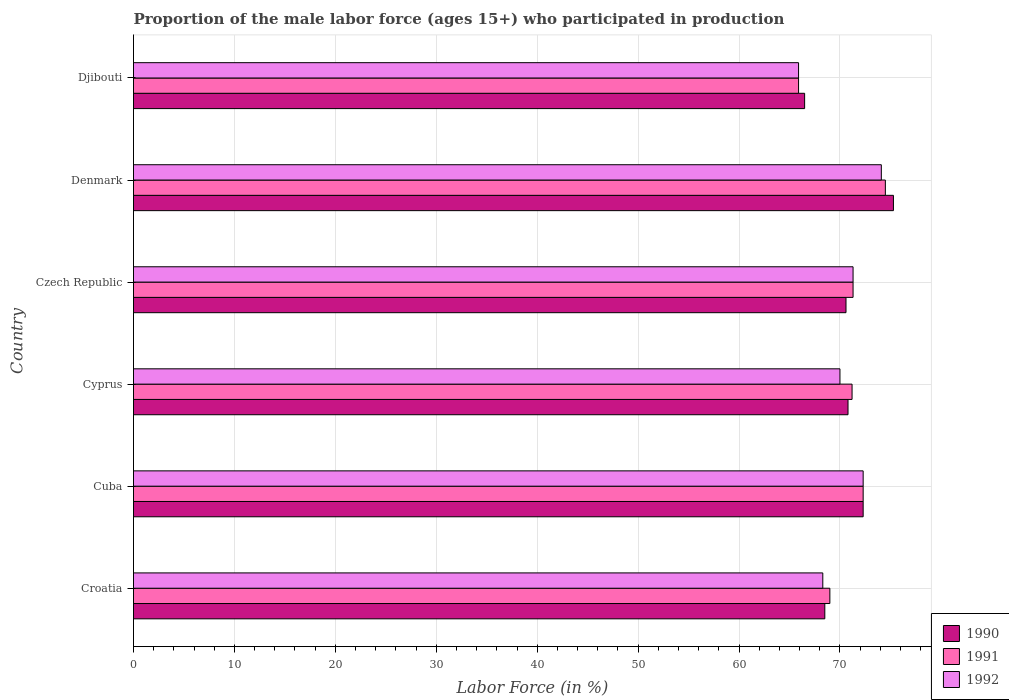Are the number of bars per tick equal to the number of legend labels?
Provide a short and direct response. Yes. How many bars are there on the 1st tick from the bottom?
Offer a very short reply. 3. What is the label of the 3rd group of bars from the top?
Give a very brief answer. Czech Republic. What is the proportion of the male labor force who participated in production in 1991 in Czech Republic?
Offer a terse response. 71.3. Across all countries, what is the maximum proportion of the male labor force who participated in production in 1990?
Your answer should be compact. 75.3. Across all countries, what is the minimum proportion of the male labor force who participated in production in 1990?
Make the answer very short. 66.5. In which country was the proportion of the male labor force who participated in production in 1992 maximum?
Give a very brief answer. Denmark. In which country was the proportion of the male labor force who participated in production in 1990 minimum?
Your response must be concise. Djibouti. What is the total proportion of the male labor force who participated in production in 1990 in the graph?
Provide a succinct answer. 424. What is the difference between the proportion of the male labor force who participated in production in 1990 in Croatia and that in Czech Republic?
Offer a terse response. -2.1. What is the difference between the proportion of the male labor force who participated in production in 1992 in Croatia and the proportion of the male labor force who participated in production in 1990 in Cuba?
Make the answer very short. -4. What is the average proportion of the male labor force who participated in production in 1991 per country?
Your response must be concise. 70.7. What is the difference between the proportion of the male labor force who participated in production in 1990 and proportion of the male labor force who participated in production in 1991 in Czech Republic?
Keep it short and to the point. -0.7. In how many countries, is the proportion of the male labor force who participated in production in 1992 greater than 30 %?
Give a very brief answer. 6. What is the ratio of the proportion of the male labor force who participated in production in 1992 in Croatia to that in Cuba?
Your response must be concise. 0.94. Is the difference between the proportion of the male labor force who participated in production in 1990 in Croatia and Cyprus greater than the difference between the proportion of the male labor force who participated in production in 1991 in Croatia and Cyprus?
Provide a succinct answer. No. What is the difference between the highest and the second highest proportion of the male labor force who participated in production in 1992?
Ensure brevity in your answer.  1.8. What is the difference between the highest and the lowest proportion of the male labor force who participated in production in 1991?
Your answer should be compact. 8.6. Is the sum of the proportion of the male labor force who participated in production in 1992 in Croatia and Cyprus greater than the maximum proportion of the male labor force who participated in production in 1990 across all countries?
Offer a terse response. Yes. What does the 3rd bar from the top in Denmark represents?
Provide a short and direct response. 1990. Are all the bars in the graph horizontal?
Your response must be concise. Yes. How many countries are there in the graph?
Your response must be concise. 6. Are the values on the major ticks of X-axis written in scientific E-notation?
Make the answer very short. No. Does the graph contain any zero values?
Provide a short and direct response. No. What is the title of the graph?
Your answer should be compact. Proportion of the male labor force (ages 15+) who participated in production. What is the label or title of the Y-axis?
Provide a short and direct response. Country. What is the Labor Force (in %) of 1990 in Croatia?
Offer a terse response. 68.5. What is the Labor Force (in %) of 1991 in Croatia?
Offer a terse response. 69. What is the Labor Force (in %) of 1992 in Croatia?
Offer a terse response. 68.3. What is the Labor Force (in %) in 1990 in Cuba?
Offer a very short reply. 72.3. What is the Labor Force (in %) of 1991 in Cuba?
Give a very brief answer. 72.3. What is the Labor Force (in %) in 1992 in Cuba?
Give a very brief answer. 72.3. What is the Labor Force (in %) in 1990 in Cyprus?
Offer a very short reply. 70.8. What is the Labor Force (in %) in 1991 in Cyprus?
Ensure brevity in your answer.  71.2. What is the Labor Force (in %) in 1990 in Czech Republic?
Offer a very short reply. 70.6. What is the Labor Force (in %) in 1991 in Czech Republic?
Offer a terse response. 71.3. What is the Labor Force (in %) in 1992 in Czech Republic?
Provide a succinct answer. 71.3. What is the Labor Force (in %) in 1990 in Denmark?
Your answer should be compact. 75.3. What is the Labor Force (in %) of 1991 in Denmark?
Offer a terse response. 74.5. What is the Labor Force (in %) in 1992 in Denmark?
Ensure brevity in your answer.  74.1. What is the Labor Force (in %) in 1990 in Djibouti?
Give a very brief answer. 66.5. What is the Labor Force (in %) in 1991 in Djibouti?
Give a very brief answer. 65.9. What is the Labor Force (in %) in 1992 in Djibouti?
Offer a very short reply. 65.9. Across all countries, what is the maximum Labor Force (in %) of 1990?
Your response must be concise. 75.3. Across all countries, what is the maximum Labor Force (in %) of 1991?
Give a very brief answer. 74.5. Across all countries, what is the maximum Labor Force (in %) in 1992?
Ensure brevity in your answer.  74.1. Across all countries, what is the minimum Labor Force (in %) of 1990?
Offer a terse response. 66.5. Across all countries, what is the minimum Labor Force (in %) in 1991?
Your answer should be very brief. 65.9. Across all countries, what is the minimum Labor Force (in %) in 1992?
Make the answer very short. 65.9. What is the total Labor Force (in %) in 1990 in the graph?
Your answer should be compact. 424. What is the total Labor Force (in %) of 1991 in the graph?
Keep it short and to the point. 424.2. What is the total Labor Force (in %) of 1992 in the graph?
Make the answer very short. 421.9. What is the difference between the Labor Force (in %) in 1990 in Croatia and that in Cyprus?
Make the answer very short. -2.3. What is the difference between the Labor Force (in %) of 1991 in Croatia and that in Cyprus?
Provide a short and direct response. -2.2. What is the difference between the Labor Force (in %) of 1992 in Croatia and that in Cyprus?
Keep it short and to the point. -1.7. What is the difference between the Labor Force (in %) of 1991 in Croatia and that in Czech Republic?
Provide a succinct answer. -2.3. What is the difference between the Labor Force (in %) of 1992 in Croatia and that in Czech Republic?
Provide a succinct answer. -3. What is the difference between the Labor Force (in %) of 1990 in Croatia and that in Djibouti?
Keep it short and to the point. 2. What is the difference between the Labor Force (in %) in 1991 in Cuba and that in Cyprus?
Keep it short and to the point. 1.1. What is the difference between the Labor Force (in %) of 1992 in Cuba and that in Cyprus?
Your response must be concise. 2.3. What is the difference between the Labor Force (in %) in 1992 in Cuba and that in Czech Republic?
Ensure brevity in your answer.  1. What is the difference between the Labor Force (in %) of 1990 in Cuba and that in Denmark?
Give a very brief answer. -3. What is the difference between the Labor Force (in %) in 1990 in Cuba and that in Djibouti?
Offer a very short reply. 5.8. What is the difference between the Labor Force (in %) of 1991 in Cuba and that in Djibouti?
Make the answer very short. 6.4. What is the difference between the Labor Force (in %) in 1992 in Cyprus and that in Czech Republic?
Provide a short and direct response. -1.3. What is the difference between the Labor Force (in %) in 1992 in Cyprus and that in Denmark?
Your response must be concise. -4.1. What is the difference between the Labor Force (in %) in 1990 in Cyprus and that in Djibouti?
Your response must be concise. 4.3. What is the difference between the Labor Force (in %) in 1991 in Cyprus and that in Djibouti?
Your response must be concise. 5.3. What is the difference between the Labor Force (in %) of 1990 in Czech Republic and that in Djibouti?
Your response must be concise. 4.1. What is the difference between the Labor Force (in %) in 1992 in Czech Republic and that in Djibouti?
Make the answer very short. 5.4. What is the difference between the Labor Force (in %) of 1992 in Denmark and that in Djibouti?
Provide a short and direct response. 8.2. What is the difference between the Labor Force (in %) of 1991 in Croatia and the Labor Force (in %) of 1992 in Cuba?
Offer a terse response. -3.3. What is the difference between the Labor Force (in %) of 1990 in Croatia and the Labor Force (in %) of 1991 in Cyprus?
Your answer should be compact. -2.7. What is the difference between the Labor Force (in %) in 1990 in Croatia and the Labor Force (in %) in 1991 in Czech Republic?
Provide a short and direct response. -2.8. What is the difference between the Labor Force (in %) in 1990 in Croatia and the Labor Force (in %) in 1992 in Czech Republic?
Your answer should be very brief. -2.8. What is the difference between the Labor Force (in %) in 1991 in Croatia and the Labor Force (in %) in 1992 in Czech Republic?
Your response must be concise. -2.3. What is the difference between the Labor Force (in %) in 1990 in Croatia and the Labor Force (in %) in 1991 in Denmark?
Provide a succinct answer. -6. What is the difference between the Labor Force (in %) of 1990 in Croatia and the Labor Force (in %) of 1992 in Djibouti?
Give a very brief answer. 2.6. What is the difference between the Labor Force (in %) in 1990 in Cuba and the Labor Force (in %) in 1992 in Cyprus?
Offer a very short reply. 2.3. What is the difference between the Labor Force (in %) in 1990 in Cuba and the Labor Force (in %) in 1992 in Czech Republic?
Your response must be concise. 1. What is the difference between the Labor Force (in %) of 1990 in Cuba and the Labor Force (in %) of 1991 in Denmark?
Offer a terse response. -2.2. What is the difference between the Labor Force (in %) in 1990 in Cyprus and the Labor Force (in %) in 1991 in Czech Republic?
Give a very brief answer. -0.5. What is the difference between the Labor Force (in %) in 1990 in Cyprus and the Labor Force (in %) in 1992 in Czech Republic?
Give a very brief answer. -0.5. What is the difference between the Labor Force (in %) of 1991 in Cyprus and the Labor Force (in %) of 1992 in Czech Republic?
Your answer should be very brief. -0.1. What is the difference between the Labor Force (in %) in 1990 in Cyprus and the Labor Force (in %) in 1991 in Denmark?
Provide a short and direct response. -3.7. What is the difference between the Labor Force (in %) of 1990 in Cyprus and the Labor Force (in %) of 1992 in Denmark?
Your response must be concise. -3.3. What is the difference between the Labor Force (in %) of 1990 in Cyprus and the Labor Force (in %) of 1992 in Djibouti?
Give a very brief answer. 4.9. What is the difference between the Labor Force (in %) of 1990 in Czech Republic and the Labor Force (in %) of 1991 in Denmark?
Offer a very short reply. -3.9. What is the difference between the Labor Force (in %) of 1990 in Czech Republic and the Labor Force (in %) of 1992 in Denmark?
Your response must be concise. -3.5. What is the difference between the Labor Force (in %) of 1990 in Czech Republic and the Labor Force (in %) of 1992 in Djibouti?
Your answer should be very brief. 4.7. What is the difference between the Labor Force (in %) of 1991 in Czech Republic and the Labor Force (in %) of 1992 in Djibouti?
Your response must be concise. 5.4. What is the difference between the Labor Force (in %) in 1990 in Denmark and the Labor Force (in %) in 1992 in Djibouti?
Keep it short and to the point. 9.4. What is the difference between the Labor Force (in %) in 1991 in Denmark and the Labor Force (in %) in 1992 in Djibouti?
Keep it short and to the point. 8.6. What is the average Labor Force (in %) in 1990 per country?
Provide a succinct answer. 70.67. What is the average Labor Force (in %) in 1991 per country?
Make the answer very short. 70.7. What is the average Labor Force (in %) in 1992 per country?
Provide a succinct answer. 70.32. What is the difference between the Labor Force (in %) in 1991 and Labor Force (in %) in 1992 in Croatia?
Make the answer very short. 0.7. What is the difference between the Labor Force (in %) of 1991 and Labor Force (in %) of 1992 in Cuba?
Ensure brevity in your answer.  0. What is the difference between the Labor Force (in %) of 1990 and Labor Force (in %) of 1992 in Cyprus?
Offer a very short reply. 0.8. What is the difference between the Labor Force (in %) in 1991 and Labor Force (in %) in 1992 in Denmark?
Provide a short and direct response. 0.4. What is the difference between the Labor Force (in %) of 1990 and Labor Force (in %) of 1992 in Djibouti?
Your answer should be compact. 0.6. What is the ratio of the Labor Force (in %) of 1990 in Croatia to that in Cuba?
Provide a succinct answer. 0.95. What is the ratio of the Labor Force (in %) of 1991 in Croatia to that in Cuba?
Provide a short and direct response. 0.95. What is the ratio of the Labor Force (in %) of 1992 in Croatia to that in Cuba?
Your response must be concise. 0.94. What is the ratio of the Labor Force (in %) in 1990 in Croatia to that in Cyprus?
Your response must be concise. 0.97. What is the ratio of the Labor Force (in %) in 1991 in Croatia to that in Cyprus?
Provide a succinct answer. 0.97. What is the ratio of the Labor Force (in %) in 1992 in Croatia to that in Cyprus?
Provide a succinct answer. 0.98. What is the ratio of the Labor Force (in %) of 1990 in Croatia to that in Czech Republic?
Your response must be concise. 0.97. What is the ratio of the Labor Force (in %) of 1991 in Croatia to that in Czech Republic?
Offer a very short reply. 0.97. What is the ratio of the Labor Force (in %) of 1992 in Croatia to that in Czech Republic?
Your answer should be very brief. 0.96. What is the ratio of the Labor Force (in %) of 1990 in Croatia to that in Denmark?
Provide a succinct answer. 0.91. What is the ratio of the Labor Force (in %) of 1991 in Croatia to that in Denmark?
Provide a short and direct response. 0.93. What is the ratio of the Labor Force (in %) of 1992 in Croatia to that in Denmark?
Make the answer very short. 0.92. What is the ratio of the Labor Force (in %) in 1990 in Croatia to that in Djibouti?
Your response must be concise. 1.03. What is the ratio of the Labor Force (in %) in 1991 in Croatia to that in Djibouti?
Provide a short and direct response. 1.05. What is the ratio of the Labor Force (in %) in 1992 in Croatia to that in Djibouti?
Your response must be concise. 1.04. What is the ratio of the Labor Force (in %) in 1990 in Cuba to that in Cyprus?
Provide a succinct answer. 1.02. What is the ratio of the Labor Force (in %) of 1991 in Cuba to that in Cyprus?
Offer a terse response. 1.02. What is the ratio of the Labor Force (in %) of 1992 in Cuba to that in Cyprus?
Your answer should be very brief. 1.03. What is the ratio of the Labor Force (in %) in 1990 in Cuba to that in Czech Republic?
Your answer should be very brief. 1.02. What is the ratio of the Labor Force (in %) of 1991 in Cuba to that in Czech Republic?
Your answer should be compact. 1.01. What is the ratio of the Labor Force (in %) in 1992 in Cuba to that in Czech Republic?
Provide a short and direct response. 1.01. What is the ratio of the Labor Force (in %) of 1990 in Cuba to that in Denmark?
Keep it short and to the point. 0.96. What is the ratio of the Labor Force (in %) in 1991 in Cuba to that in Denmark?
Your response must be concise. 0.97. What is the ratio of the Labor Force (in %) of 1992 in Cuba to that in Denmark?
Keep it short and to the point. 0.98. What is the ratio of the Labor Force (in %) in 1990 in Cuba to that in Djibouti?
Make the answer very short. 1.09. What is the ratio of the Labor Force (in %) of 1991 in Cuba to that in Djibouti?
Keep it short and to the point. 1.1. What is the ratio of the Labor Force (in %) in 1992 in Cuba to that in Djibouti?
Provide a short and direct response. 1.1. What is the ratio of the Labor Force (in %) in 1990 in Cyprus to that in Czech Republic?
Offer a terse response. 1. What is the ratio of the Labor Force (in %) of 1992 in Cyprus to that in Czech Republic?
Ensure brevity in your answer.  0.98. What is the ratio of the Labor Force (in %) of 1990 in Cyprus to that in Denmark?
Provide a short and direct response. 0.94. What is the ratio of the Labor Force (in %) of 1991 in Cyprus to that in Denmark?
Offer a terse response. 0.96. What is the ratio of the Labor Force (in %) in 1992 in Cyprus to that in Denmark?
Give a very brief answer. 0.94. What is the ratio of the Labor Force (in %) of 1990 in Cyprus to that in Djibouti?
Make the answer very short. 1.06. What is the ratio of the Labor Force (in %) in 1991 in Cyprus to that in Djibouti?
Your answer should be compact. 1.08. What is the ratio of the Labor Force (in %) of 1992 in Cyprus to that in Djibouti?
Provide a succinct answer. 1.06. What is the ratio of the Labor Force (in %) of 1990 in Czech Republic to that in Denmark?
Offer a terse response. 0.94. What is the ratio of the Labor Force (in %) in 1991 in Czech Republic to that in Denmark?
Provide a succinct answer. 0.96. What is the ratio of the Labor Force (in %) in 1992 in Czech Republic to that in Denmark?
Make the answer very short. 0.96. What is the ratio of the Labor Force (in %) of 1990 in Czech Republic to that in Djibouti?
Provide a succinct answer. 1.06. What is the ratio of the Labor Force (in %) in 1991 in Czech Republic to that in Djibouti?
Your response must be concise. 1.08. What is the ratio of the Labor Force (in %) of 1992 in Czech Republic to that in Djibouti?
Make the answer very short. 1.08. What is the ratio of the Labor Force (in %) in 1990 in Denmark to that in Djibouti?
Provide a short and direct response. 1.13. What is the ratio of the Labor Force (in %) of 1991 in Denmark to that in Djibouti?
Give a very brief answer. 1.13. What is the ratio of the Labor Force (in %) of 1992 in Denmark to that in Djibouti?
Make the answer very short. 1.12. What is the difference between the highest and the second highest Labor Force (in %) of 1992?
Keep it short and to the point. 1.8. What is the difference between the highest and the lowest Labor Force (in %) of 1990?
Ensure brevity in your answer.  8.8. What is the difference between the highest and the lowest Labor Force (in %) of 1991?
Offer a terse response. 8.6. What is the difference between the highest and the lowest Labor Force (in %) of 1992?
Give a very brief answer. 8.2. 